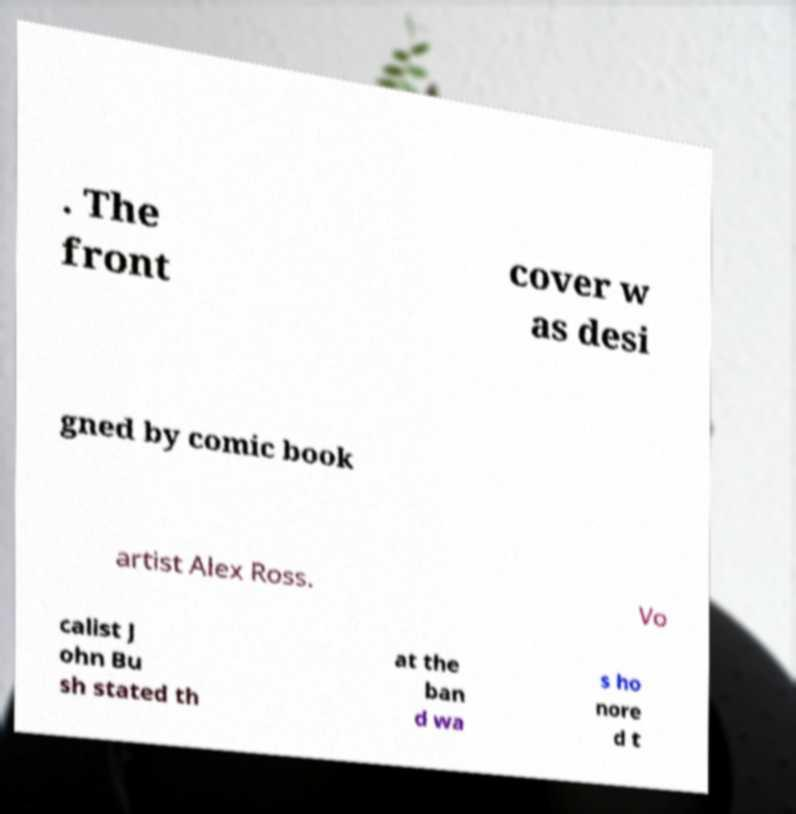Can you accurately transcribe the text from the provided image for me? . The front cover w as desi gned by comic book artist Alex Ross. Vo calist J ohn Bu sh stated th at the ban d wa s ho nore d t 